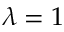Convert formula to latex. <formula><loc_0><loc_0><loc_500><loc_500>\lambda = 1</formula> 